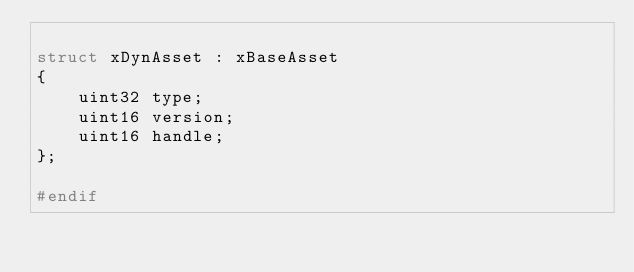Convert code to text. <code><loc_0><loc_0><loc_500><loc_500><_C_>
struct xDynAsset : xBaseAsset
{
    uint32 type;
    uint16 version;
    uint16 handle;
};

#endif</code> 